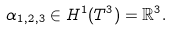<formula> <loc_0><loc_0><loc_500><loc_500>\alpha _ { 1 , 2 , 3 } \in H ^ { 1 } ( T ^ { 3 } ) = \mathbb { R } ^ { 3 } .</formula> 